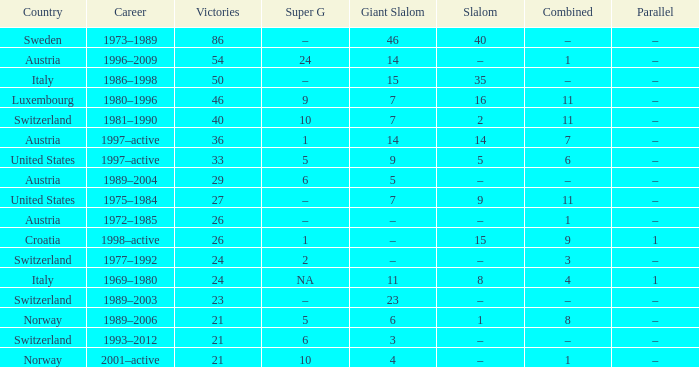What Super G has a Career of 1980–1996? 9.0. 